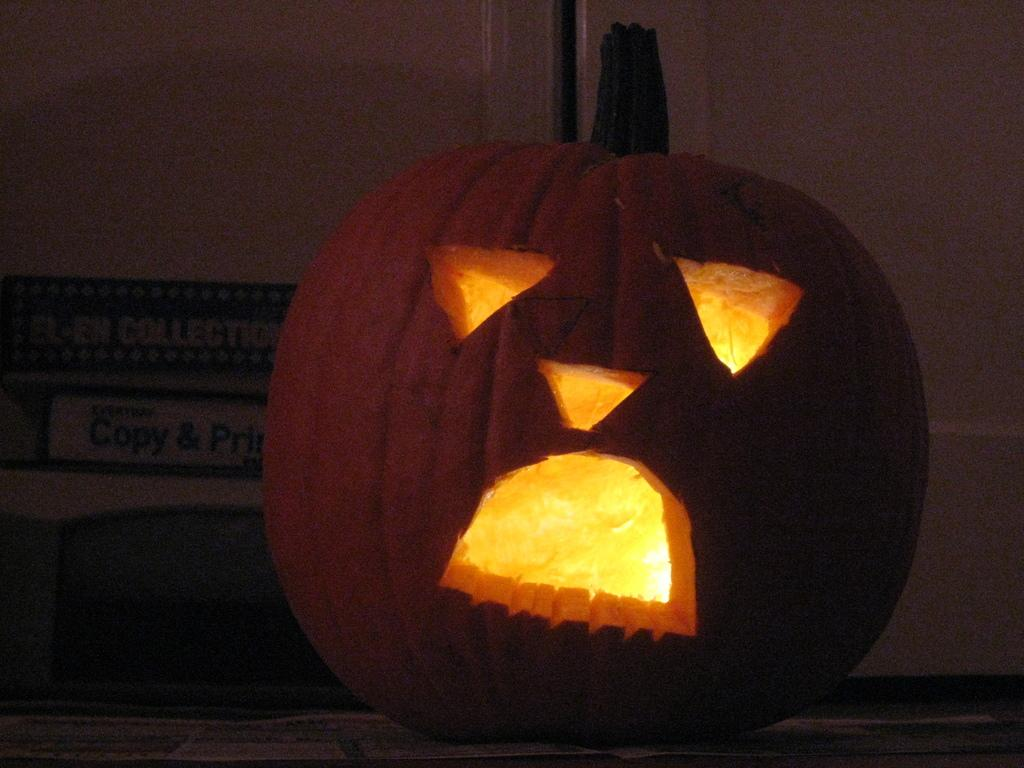What is the main object in the image? There is a pumpkin in the image. How has the pumpkin been modified? The pumpkin is carved. What is inside the carved pumpkin? There are lights inside the pumpkin. What can be seen behind the pumpkin? There is a wall behind the pumpkin. What is written or depicted on the wall? There is text on the wall to the left of the pumpkin. Can you tell me how many chess pieces are on the pumpkin in the image? There are no chess pieces present on the pumpkin in the image. What type of underwear is hanging on the wall behind the pumpkin? There is no underwear present on the wall behind the pumpkin in the image. 